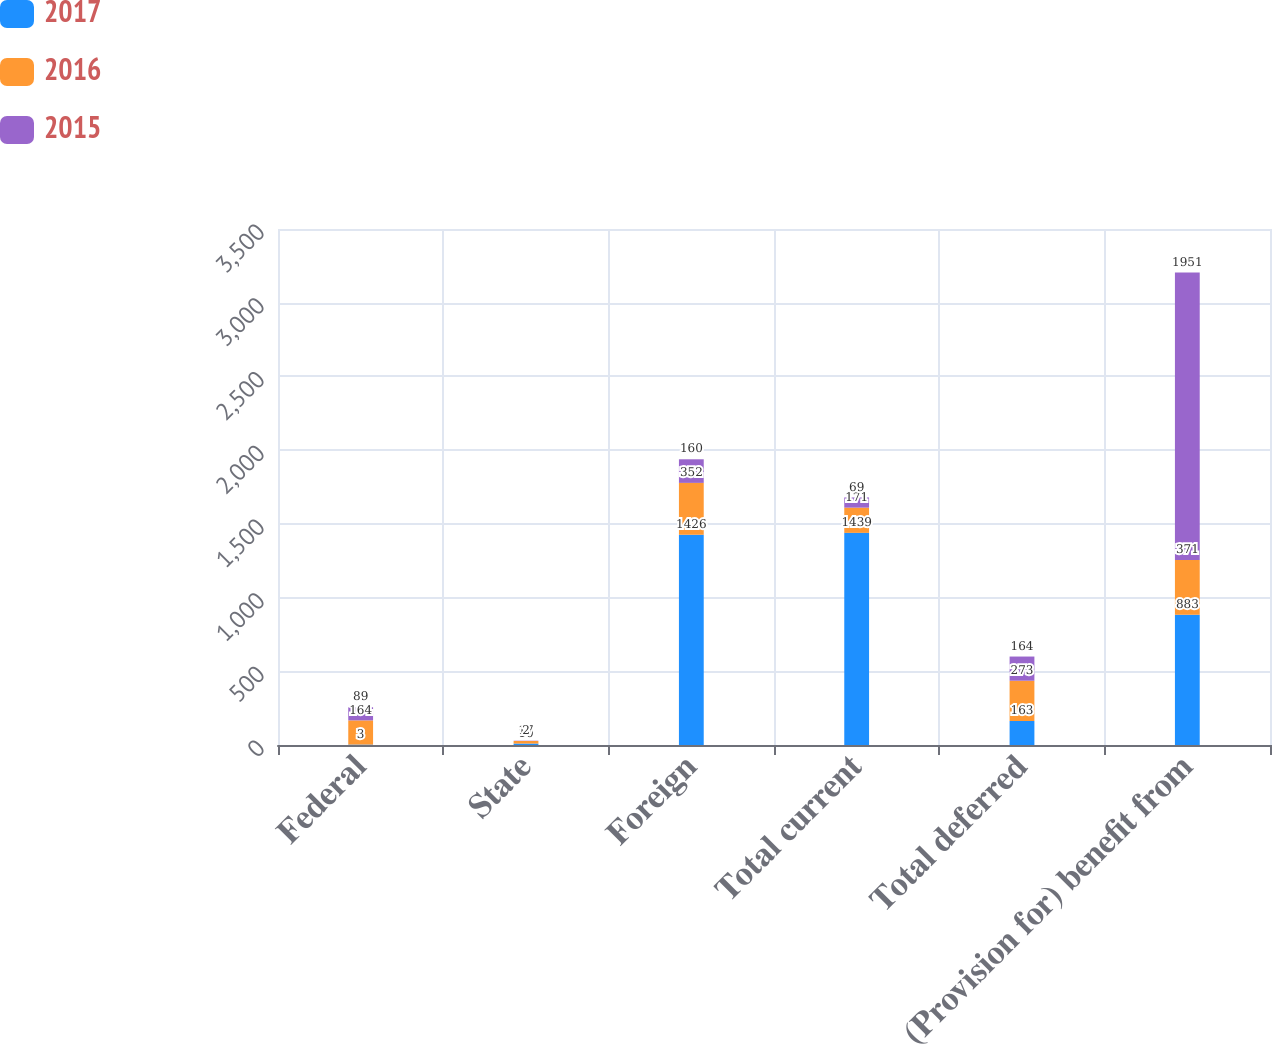Convert chart to OTSL. <chart><loc_0><loc_0><loc_500><loc_500><stacked_bar_chart><ecel><fcel>Federal<fcel>State<fcel>Foreign<fcel>Total current<fcel>Total deferred<fcel>(Provision for) benefit from<nl><fcel>2017<fcel>3<fcel>10<fcel>1426<fcel>1439<fcel>163<fcel>883<nl><fcel>2016<fcel>164<fcel>17<fcel>352<fcel>171<fcel>273<fcel>371<nl><fcel>2015<fcel>89<fcel>2<fcel>160<fcel>69<fcel>164<fcel>1951<nl></chart> 